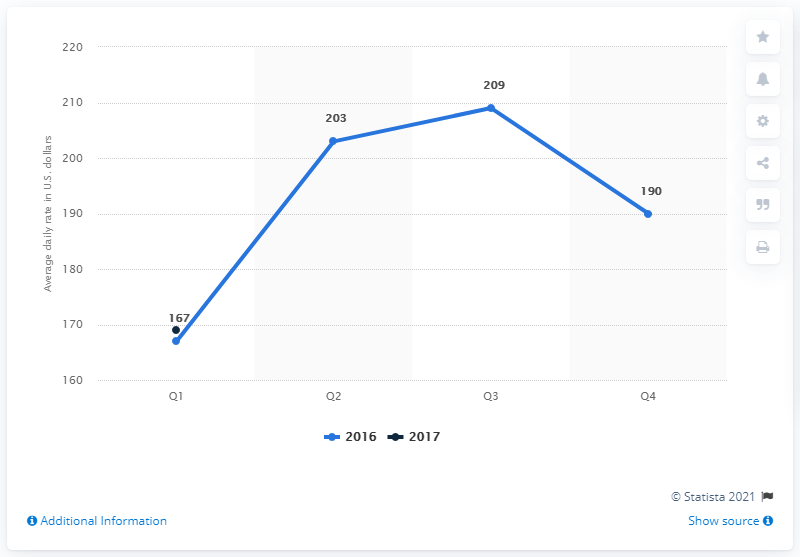Mention a couple of crucial points in this snapshot. The average daily rate of hotels in Philadelphia was $169 in the first quarter of 2017. 